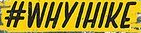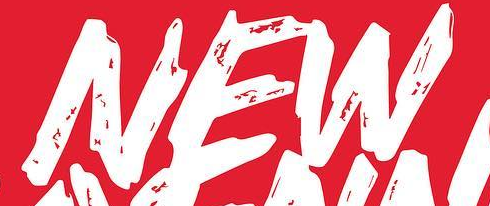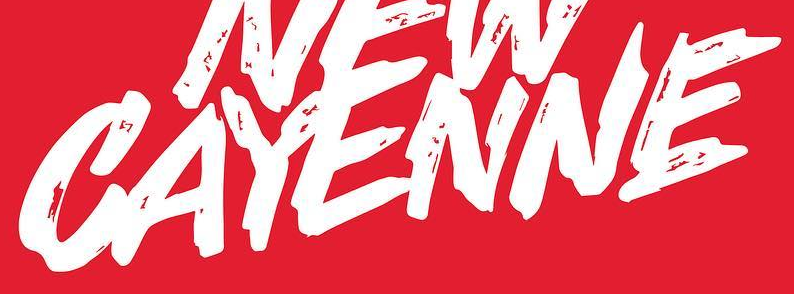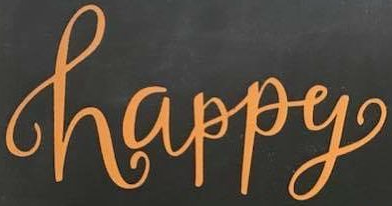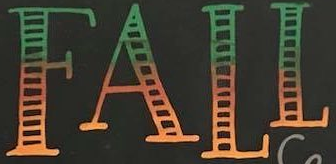Read the text content from these images in order, separated by a semicolon. #WHYIHIKE; NEW; CAYENNE; happy; FALL 